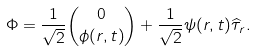Convert formula to latex. <formula><loc_0><loc_0><loc_500><loc_500>\Phi = \frac { 1 } { \sqrt { 2 } } { 0 \choose \phi ( r , t ) } + \frac { 1 } { \sqrt { 2 } } \psi ( r , t ) \widehat { \tau } _ { r } .</formula> 